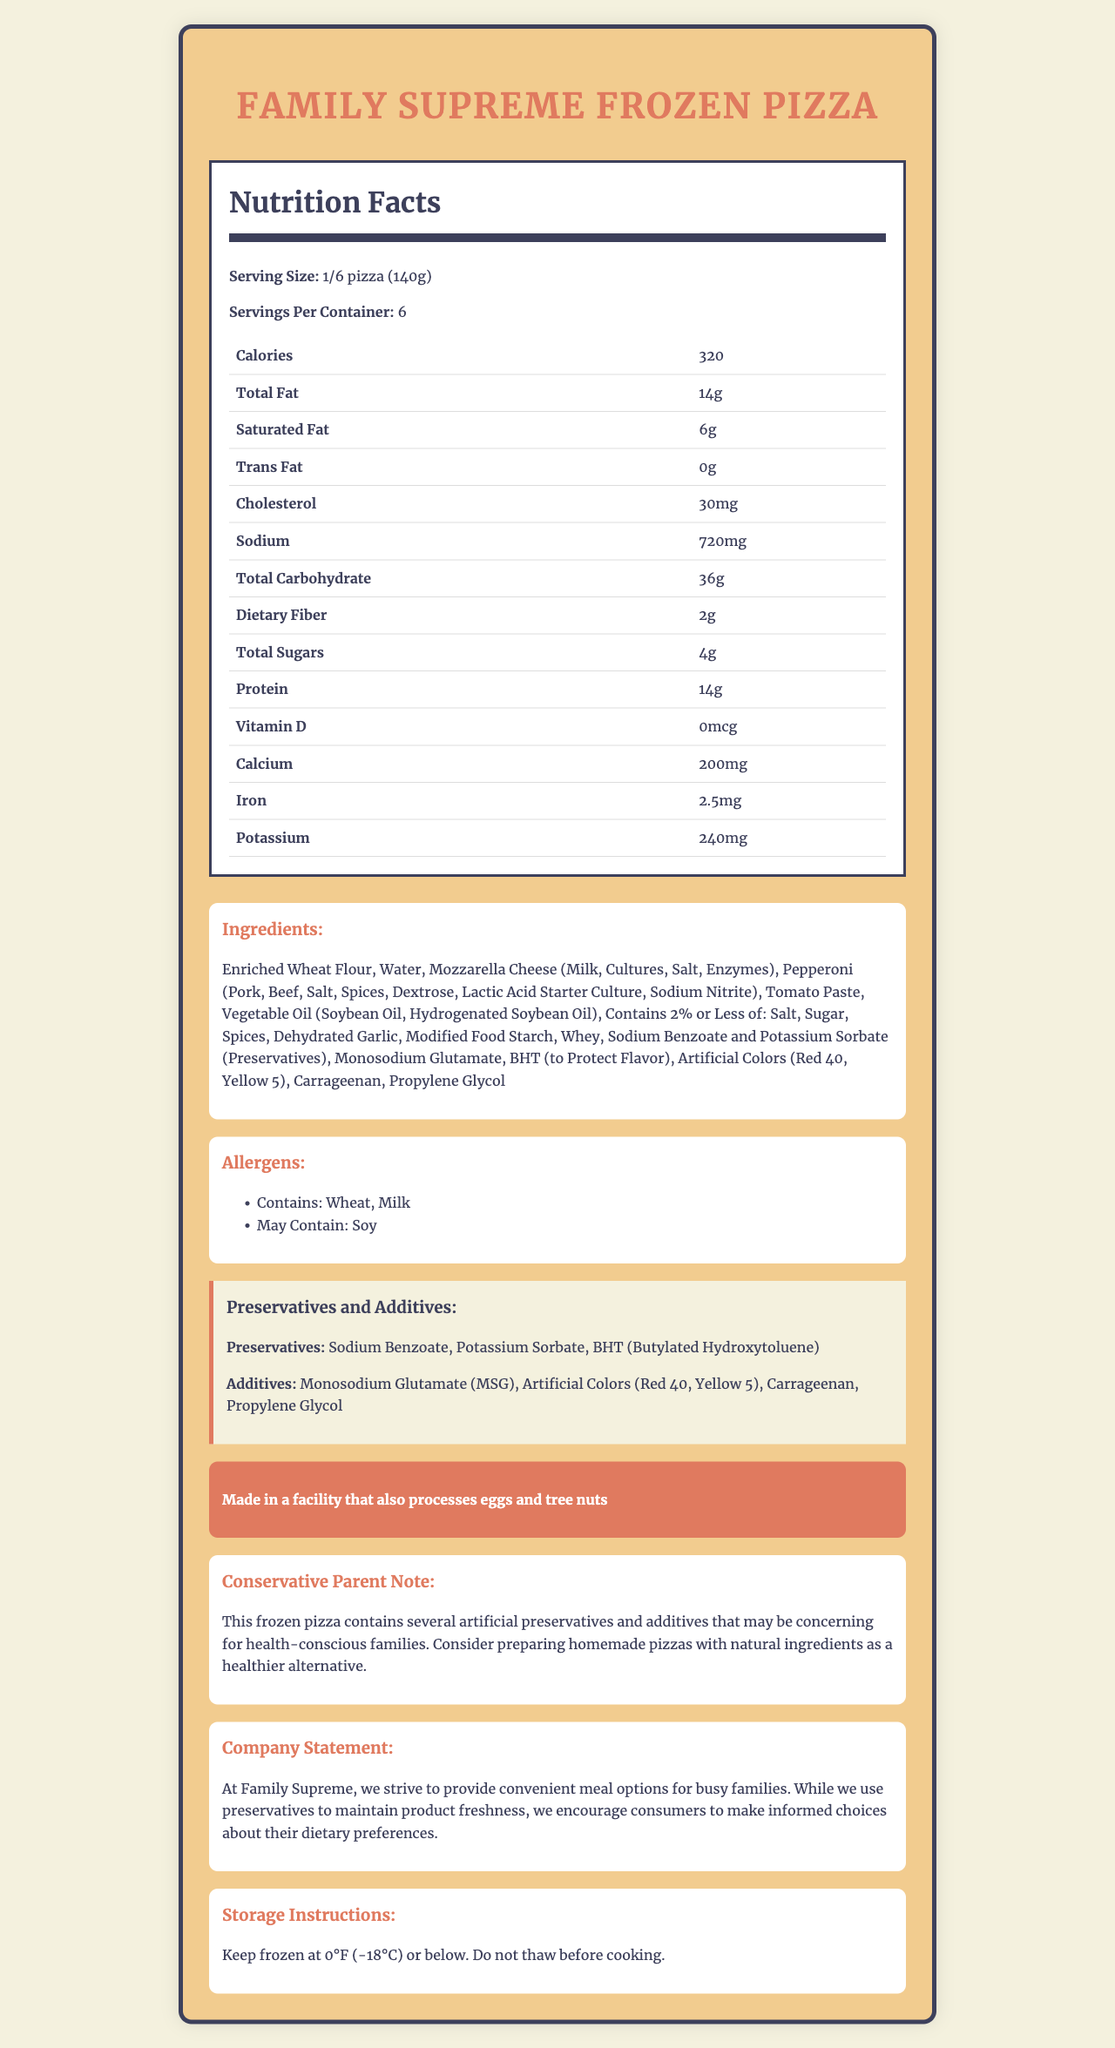what is the serving size for the Family Supreme Frozen Pizza? The document specifies the serving size as "1/6 pizza (140g)".
Answer: 1/6 pizza (140g) how many servings are there per container? The Nutrition Facts section of the document lists "Servings Per Container: 6".
Answer: 6 what ingredients in the Family Supreme Frozen Pizza may trigger allergies? The Allergens section mentions: "Contains: Wheat, Milk" and "May Contain: Soy".
Answer: Wheat, Milk, Soy which additive might be used to enhance flavor? The list of additives includes "Monosodium Glutamate (MSG)", which is commonly used to enhance flavor.
Answer: Monosodium Glutamate (MSG) what is the amount of protein per serving? The Nutrition Facts table lists the protein content as "14g".
Answer: 14g Which of the following preservatives is included in the Family Supreme Frozen Pizza? A. Sorbic Acid B. Sodium Benzoate C. Citric Acid The list of preservatives in the document includes "Sodium Benzoate".
Answer: B How much sodium does each serving of the pizza contain? A. 500mg B. 600mg C. 720mg The Nutrition Facts section lists the sodium content as "720mg" per serving.
Answer: C Does the pizza contain any artificial colors? The document includes "Artificial Colors (Red 40, Yellow 5)" in the list of additives.
Answer: Yes Are there any hydrogenated oils in the ingredients? The ingredient list mentions "Hydrogenated Soybean Oil".
Answer: Yes Summarize the key details about the Family Supreme Frozen Pizza as presented in the document. This summary encapsulates the serving size, nutritional content, preservatives, additives, allergens, storage instructions, and the advice note from a conservative parent perspective.
Answer: The Family Supreme Frozen Pizza has a serving size of 1/6 pizza (140g) with 6 servings per container. Each serving provides 320 calories and contains 14g of protein. It includes preservatives like Sodium Benzoate and additives such as Monosodium Glutamate. Allergens in the pizza are Wheat, Milk, and possibly Soy. The product is made in a facility that processes eggs and tree nuts, and it requires being kept frozen at 0°F (-18°C) or below. A note advises health-conscious families to consider homemade pizzas with natural ingredients as a healthier alternative. Are there any nutrition benefits highlighted for the Family Supreme Frozen Pizza? The document does not emphasize any particular nutritional benefits.
Answer: No what is the general advice given to conservative parents regarding this product? The note advises that due to the presence of artificial preservatives and additives, health-conscious families might prefer making homemade pizzas using natural ingredients.
Answer: Consider preparing homemade pizzas with natural ingredients Does this product contain any propylene glycol? The list of additives in the document clearly includes "Propylene Glycol".
Answer: Yes where is the Family Supreme Frozen Pizza manufactured? The warning section specifies this manufacturing detail.
Answer: In a facility that also processes eggs and tree nuts what is the exact amount of iron provided by a single serving of this pizza? According to the Nutrition Facts table, a single serving contains "2.5mg" of iron.
Answer: 2.5mg Which of the following preservatives is not mentioned in the document? A. Sodium Benzoate B. Potassium Sorbate C. Sodium Nitrate D. BHT (Butylated Hydroxytoluene) The preservatives listed in the document are Sodium Benzoate, Potassium Sorbate, and BHT (Butylated Hydroxytoluene); Sodium Nitrate is not mentioned.
Answer: C Can the actual processing efficiency at the facility be determined from the document? The document does not provide any information about the processing efficiency at the facility.
Answer: Cannot be determined 